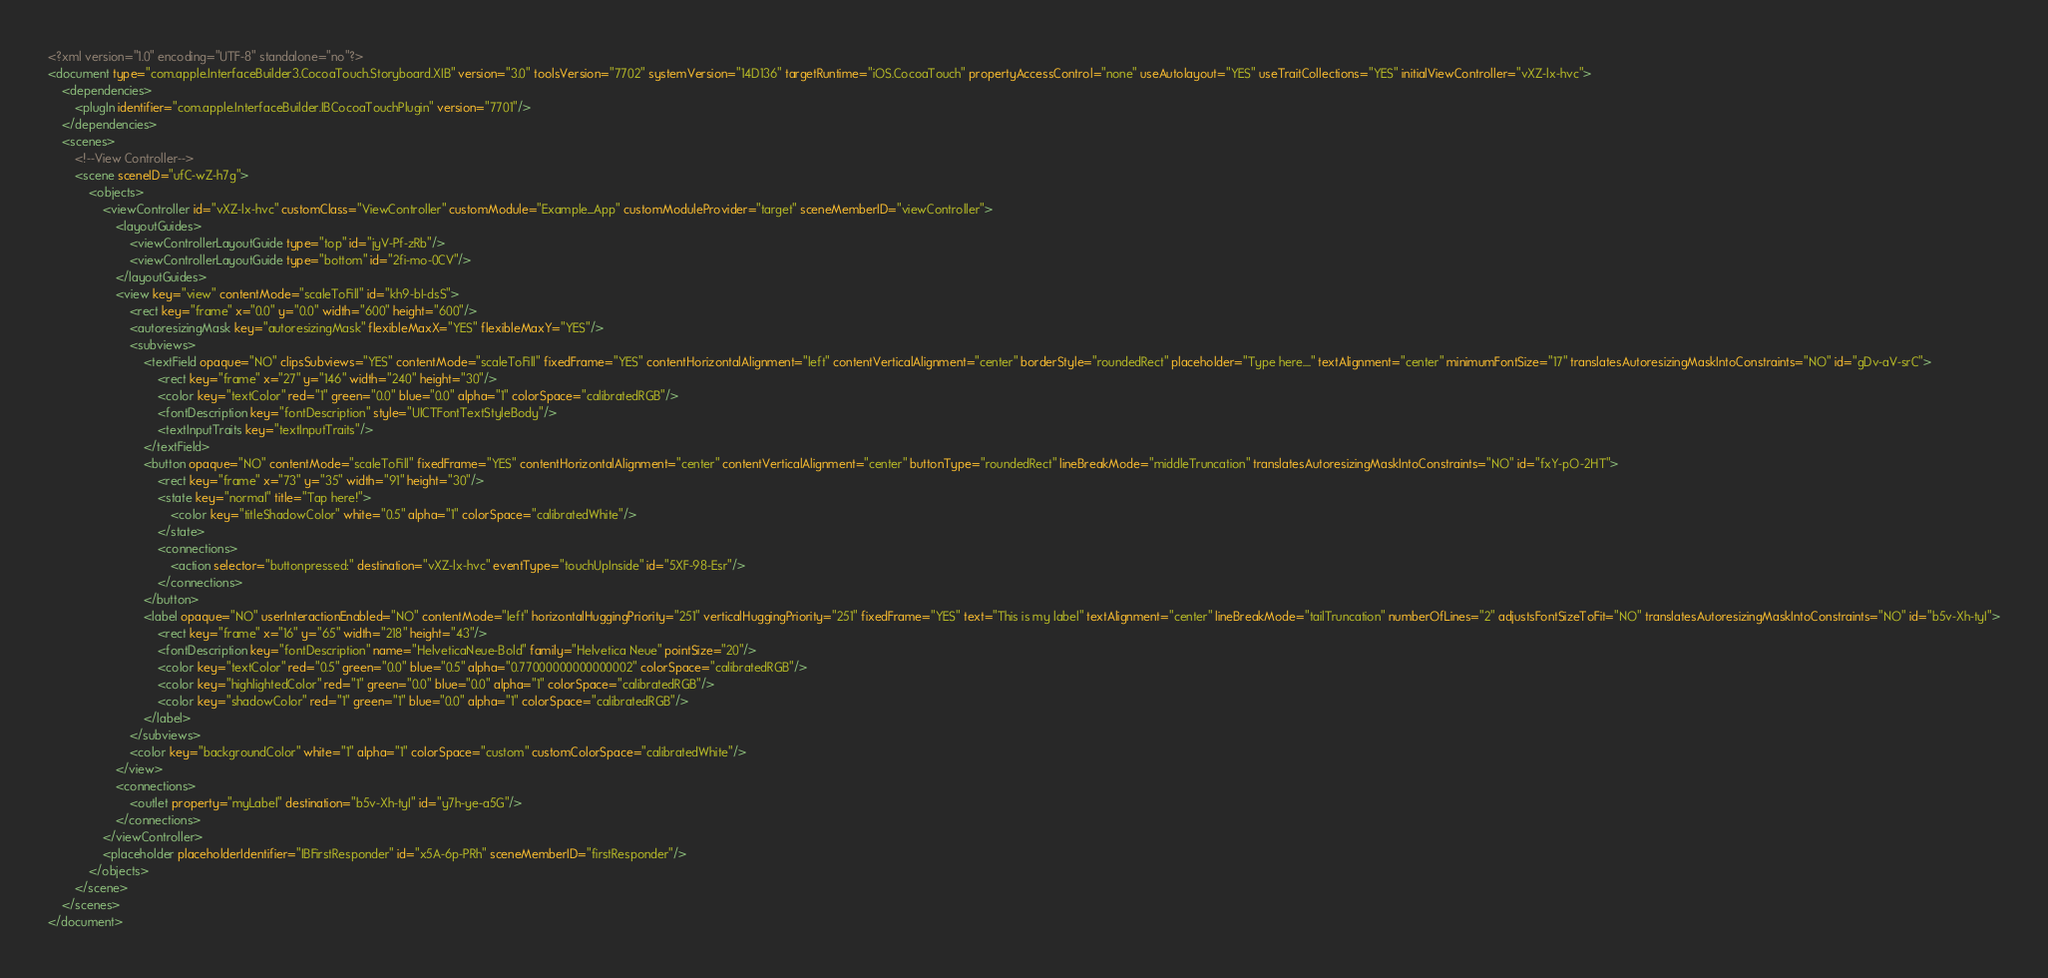Convert code to text. <code><loc_0><loc_0><loc_500><loc_500><_XML_><?xml version="1.0" encoding="UTF-8" standalone="no"?>
<document type="com.apple.InterfaceBuilder3.CocoaTouch.Storyboard.XIB" version="3.0" toolsVersion="7702" systemVersion="14D136" targetRuntime="iOS.CocoaTouch" propertyAccessControl="none" useAutolayout="YES" useTraitCollections="YES" initialViewController="vXZ-lx-hvc">
    <dependencies>
        <plugIn identifier="com.apple.InterfaceBuilder.IBCocoaTouchPlugin" version="7701"/>
    </dependencies>
    <scenes>
        <!--View Controller-->
        <scene sceneID="ufC-wZ-h7g">
            <objects>
                <viewController id="vXZ-lx-hvc" customClass="ViewController" customModule="Example_App" customModuleProvider="target" sceneMemberID="viewController">
                    <layoutGuides>
                        <viewControllerLayoutGuide type="top" id="jyV-Pf-zRb"/>
                        <viewControllerLayoutGuide type="bottom" id="2fi-mo-0CV"/>
                    </layoutGuides>
                    <view key="view" contentMode="scaleToFill" id="kh9-bI-dsS">
                        <rect key="frame" x="0.0" y="0.0" width="600" height="600"/>
                        <autoresizingMask key="autoresizingMask" flexibleMaxX="YES" flexibleMaxY="YES"/>
                        <subviews>
                            <textField opaque="NO" clipsSubviews="YES" contentMode="scaleToFill" fixedFrame="YES" contentHorizontalAlignment="left" contentVerticalAlignment="center" borderStyle="roundedRect" placeholder="Type here...." textAlignment="center" minimumFontSize="17" translatesAutoresizingMaskIntoConstraints="NO" id="gDv-aV-srC">
                                <rect key="frame" x="27" y="146" width="240" height="30"/>
                                <color key="textColor" red="1" green="0.0" blue="0.0" alpha="1" colorSpace="calibratedRGB"/>
                                <fontDescription key="fontDescription" style="UICTFontTextStyleBody"/>
                                <textInputTraits key="textInputTraits"/>
                            </textField>
                            <button opaque="NO" contentMode="scaleToFill" fixedFrame="YES" contentHorizontalAlignment="center" contentVerticalAlignment="center" buttonType="roundedRect" lineBreakMode="middleTruncation" translatesAutoresizingMaskIntoConstraints="NO" id="fxY-pO-2HT">
                                <rect key="frame" x="73" y="35" width="91" height="30"/>
                                <state key="normal" title="Tap here!">
                                    <color key="titleShadowColor" white="0.5" alpha="1" colorSpace="calibratedWhite"/>
                                </state>
                                <connections>
                                    <action selector="buttonpressed:" destination="vXZ-lx-hvc" eventType="touchUpInside" id="5XF-98-Esr"/>
                                </connections>
                            </button>
                            <label opaque="NO" userInteractionEnabled="NO" contentMode="left" horizontalHuggingPriority="251" verticalHuggingPriority="251" fixedFrame="YES" text="This is my label" textAlignment="center" lineBreakMode="tailTruncation" numberOfLines="2" adjustsFontSizeToFit="NO" translatesAutoresizingMaskIntoConstraints="NO" id="b5v-Xh-tyI">
                                <rect key="frame" x="16" y="65" width="218" height="43"/>
                                <fontDescription key="fontDescription" name="HelveticaNeue-Bold" family="Helvetica Neue" pointSize="20"/>
                                <color key="textColor" red="0.5" green="0.0" blue="0.5" alpha="0.77000000000000002" colorSpace="calibratedRGB"/>
                                <color key="highlightedColor" red="1" green="0.0" blue="0.0" alpha="1" colorSpace="calibratedRGB"/>
                                <color key="shadowColor" red="1" green="1" blue="0.0" alpha="1" colorSpace="calibratedRGB"/>
                            </label>
                        </subviews>
                        <color key="backgroundColor" white="1" alpha="1" colorSpace="custom" customColorSpace="calibratedWhite"/>
                    </view>
                    <connections>
                        <outlet property="myLabel" destination="b5v-Xh-tyI" id="y7h-ye-a5G"/>
                    </connections>
                </viewController>
                <placeholder placeholderIdentifier="IBFirstResponder" id="x5A-6p-PRh" sceneMemberID="firstResponder"/>
            </objects>
        </scene>
    </scenes>
</document>
</code> 